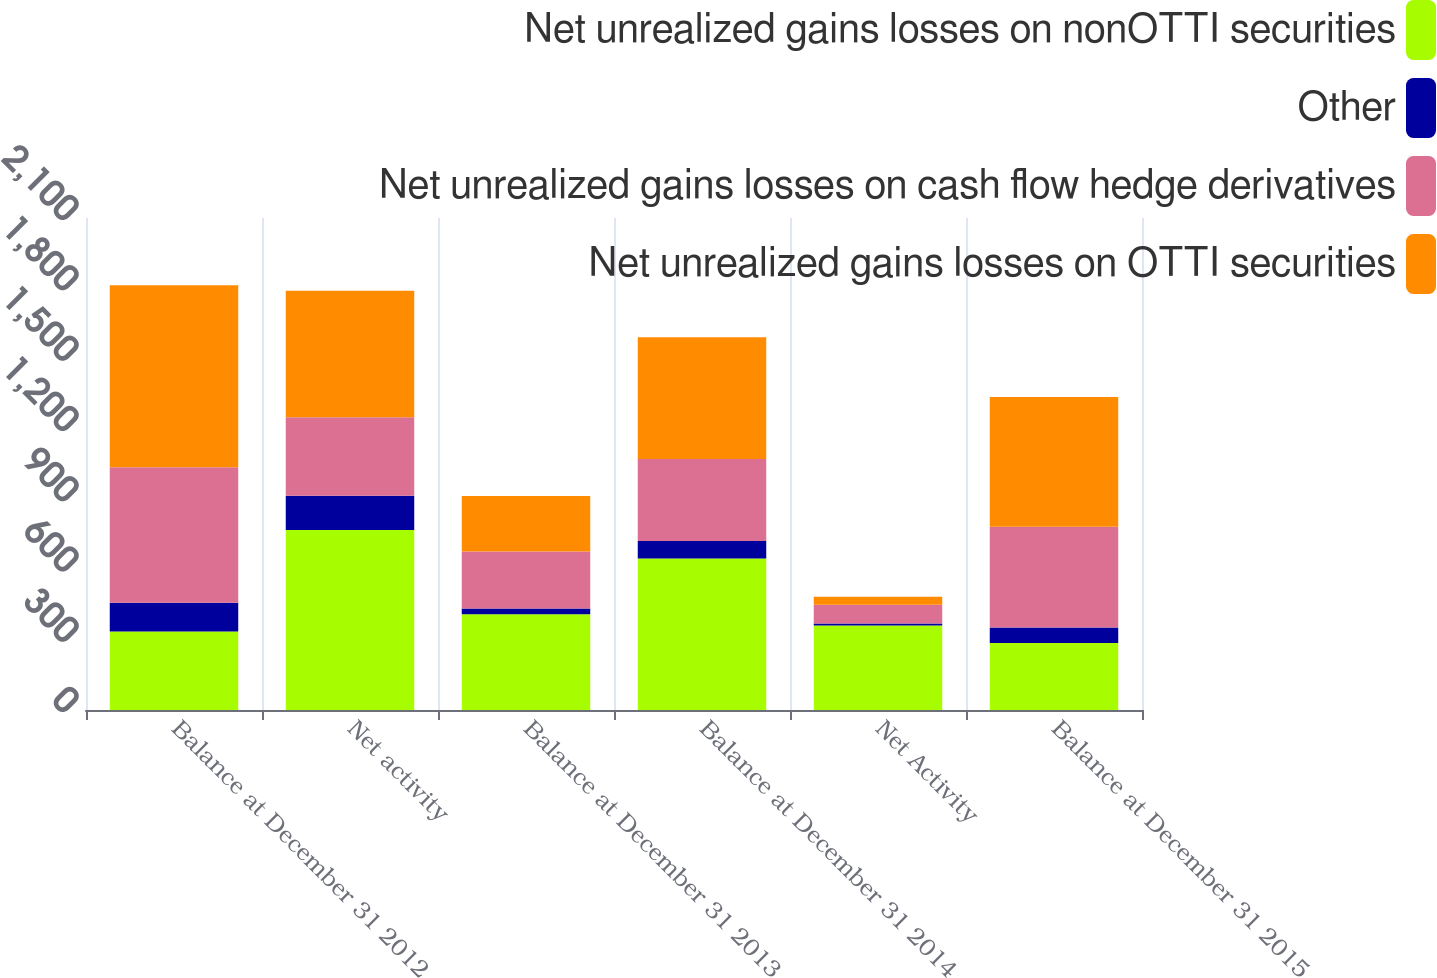Convert chart. <chart><loc_0><loc_0><loc_500><loc_500><stacked_bar_chart><ecel><fcel>Balance at December 31 2012<fcel>Net activity<fcel>Balance at December 31 2013<fcel>Balance at December 31 2014<fcel>Net Activity<fcel>Balance at December 31 2015<nl><fcel>Net unrealized gains losses on nonOTTI securities<fcel>335<fcel>768<fcel>409<fcel>647<fcel>361<fcel>286<nl><fcel>Other<fcel>123<fcel>147<fcel>24<fcel>74<fcel>8<fcel>66<nl><fcel>Net unrealized gains losses on cash flow hedge derivatives<fcel>578<fcel>335<fcel>243<fcel>350<fcel>80<fcel>430<nl><fcel>Net unrealized gains losses on OTTI securities<fcel>777<fcel>540<fcel>237<fcel>520<fcel>34<fcel>554<nl></chart> 